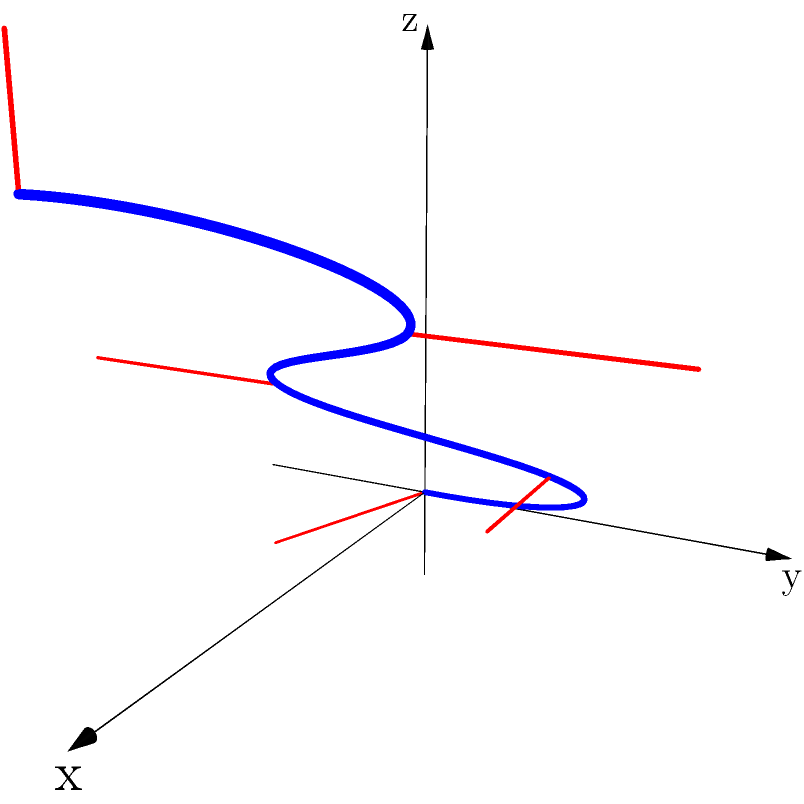Based on the 2D representation of a protein structure shown above, which of the following best describes the 3D conformation of the protein?

A) An alpha helix
B) A beta sheet
C) A random coil
D) A globular structure To determine the 3D conformation of the protein from its 2D representation, we need to analyze the following aspects:

1. Backbone structure: The blue line represents the protein backbone, which shows a non-regular, winding path through 3D space.

2. Side chains: The red lines represent side chains, which are projecting outwards from the backbone at various angles.

3. Overall shape: The protein doesn't form a regular, repeating structure like an alpha helix or a beta sheet.

4. Compactness: The structure appears to fold back on itself, occupying a relatively compact 3D space.

5. Irregularity: The backbone and side chains do not follow a consistent pattern, indicating a lack of regular secondary structure.

Given these observations:

- It's not an alpha helix, which would appear as a regular spiral.
- It's not a beta sheet, which would have a more extended, planar structure.
- While it has some random elements, it's not entirely a random coil as it shows some compactness.
- The irregular, compact nature of the structure best fits the description of a globular protein.

Therefore, the best description of this protein's 3D conformation is a globular structure.
Answer: D) A globular structure 